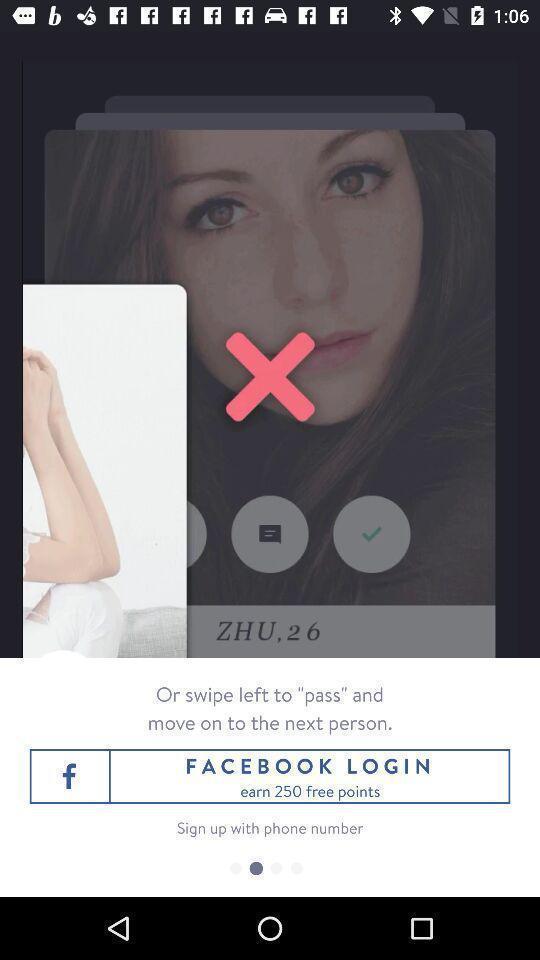What is the overall content of this screenshot? Pop up for login page of social networking app. 